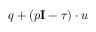Convert formula to latex. <formula><loc_0><loc_0><loc_500><loc_500>q + ( p I - \tau ) \cdot u</formula> 